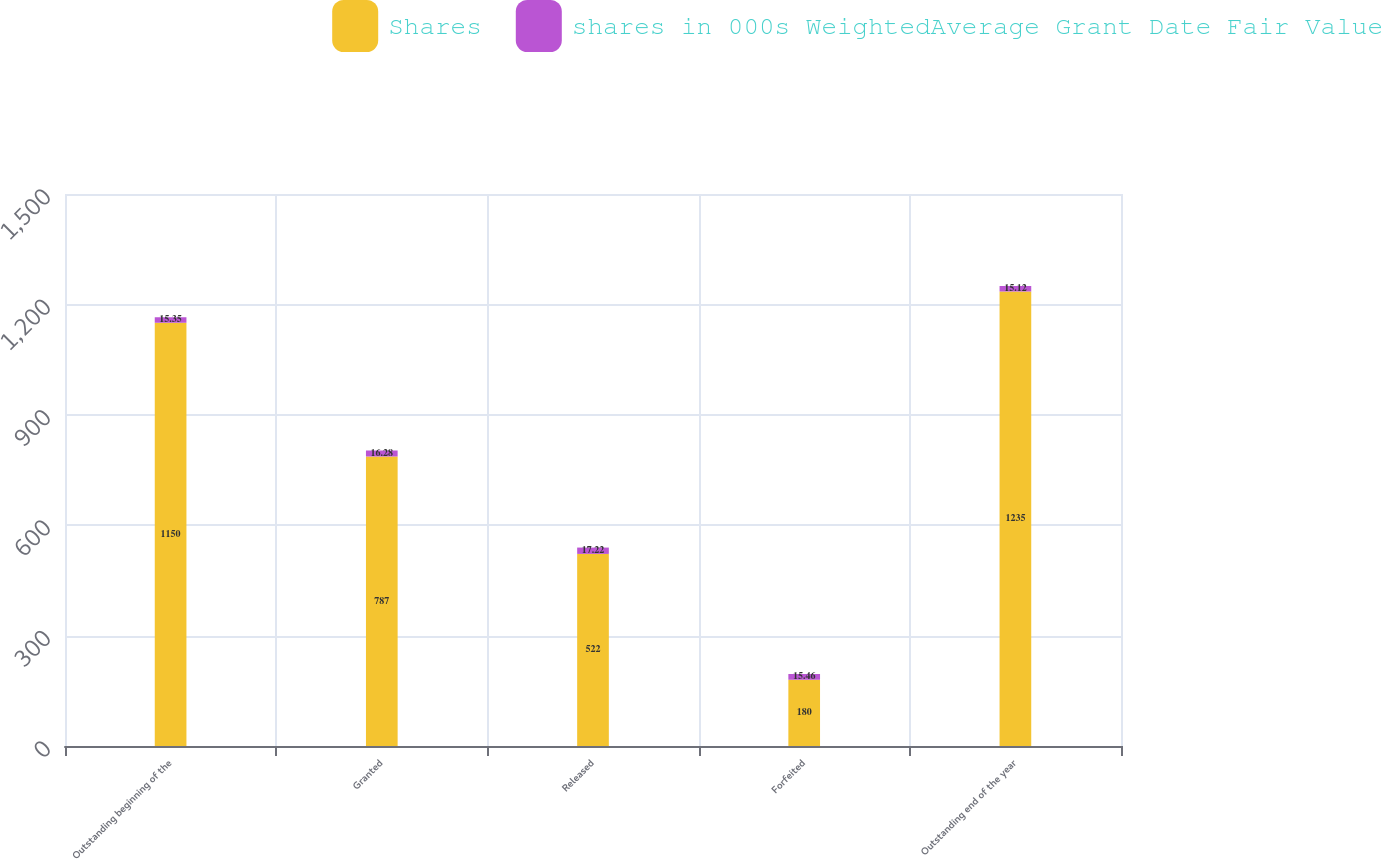Convert chart to OTSL. <chart><loc_0><loc_0><loc_500><loc_500><stacked_bar_chart><ecel><fcel>Outstanding beginning of the<fcel>Granted<fcel>Released<fcel>Forfeited<fcel>Outstanding end of the year<nl><fcel>Shares<fcel>1150<fcel>787<fcel>522<fcel>180<fcel>1235<nl><fcel>shares in 000s WeightedAverage Grant Date Fair Value<fcel>15.35<fcel>16.28<fcel>17.22<fcel>15.46<fcel>15.12<nl></chart> 